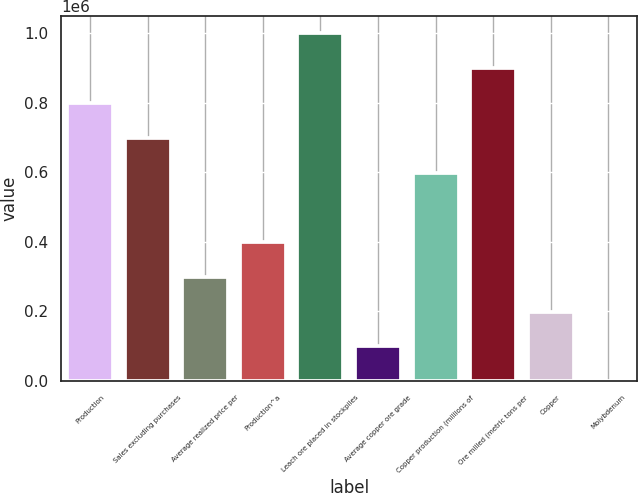<chart> <loc_0><loc_0><loc_500><loc_500><bar_chart><fcel>Production<fcel>Sales excluding purchases<fcel>Average realized price per<fcel>Production^a<fcel>Leach ore placed in stockpiles<fcel>Average copper ore grade<fcel>Copper production (millions of<fcel>Ore milled (metric tons per<fcel>Copper<fcel>Molybdenum<nl><fcel>798880<fcel>699020<fcel>299580<fcel>399440<fcel>998600<fcel>99860<fcel>599160<fcel>898740<fcel>199720<fcel>0.03<nl></chart> 